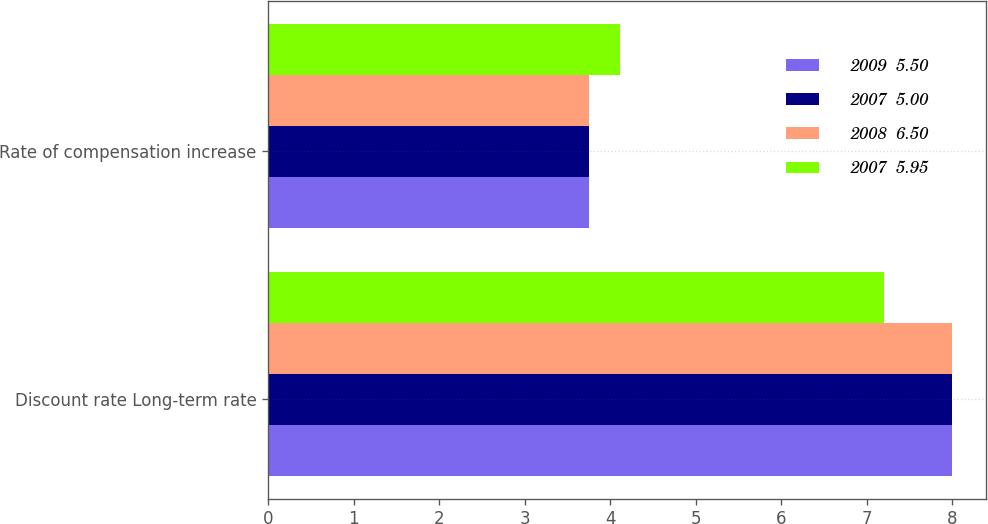Convert chart to OTSL. <chart><loc_0><loc_0><loc_500><loc_500><stacked_bar_chart><ecel><fcel>Discount rate Long-term rate<fcel>Rate of compensation increase<nl><fcel>2009  5.50<fcel>8<fcel>3.75<nl><fcel>2007  5.00<fcel>8<fcel>3.75<nl><fcel>2008  6.50<fcel>8<fcel>3.75<nl><fcel>2007  5.95<fcel>7.2<fcel>4.11<nl></chart> 